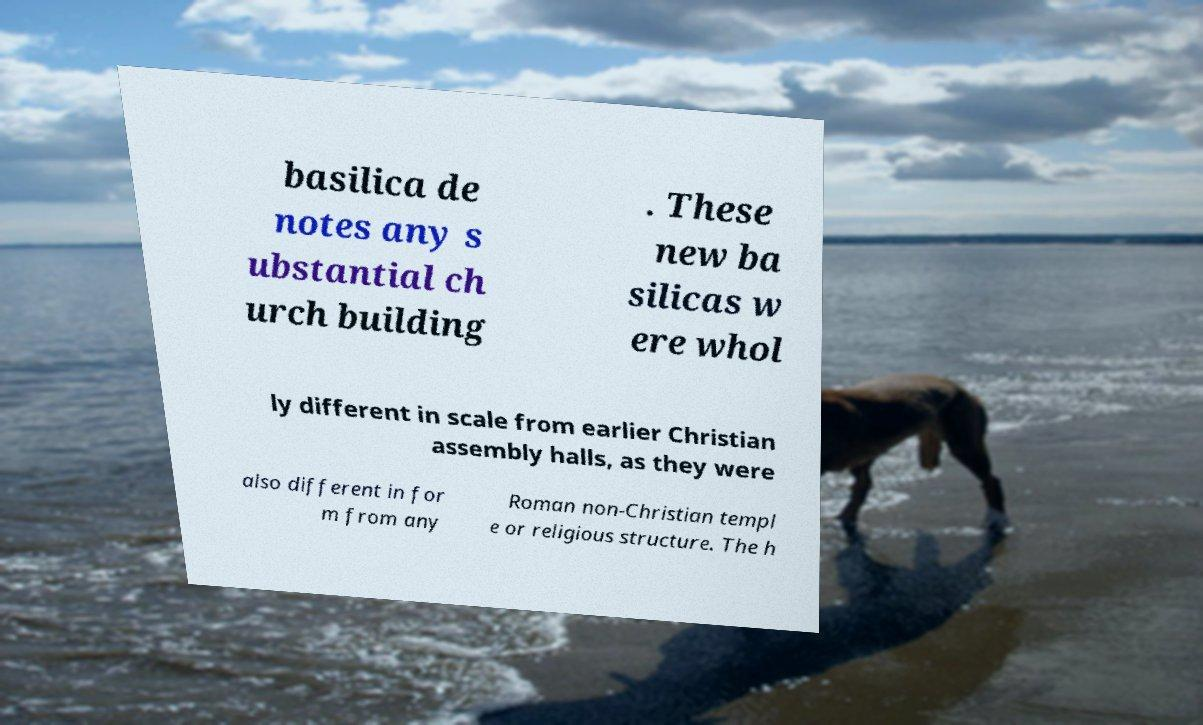For documentation purposes, I need the text within this image transcribed. Could you provide that? basilica de notes any s ubstantial ch urch building . These new ba silicas w ere whol ly different in scale from earlier Christian assembly halls, as they were also different in for m from any Roman non-Christian templ e or religious structure. The h 